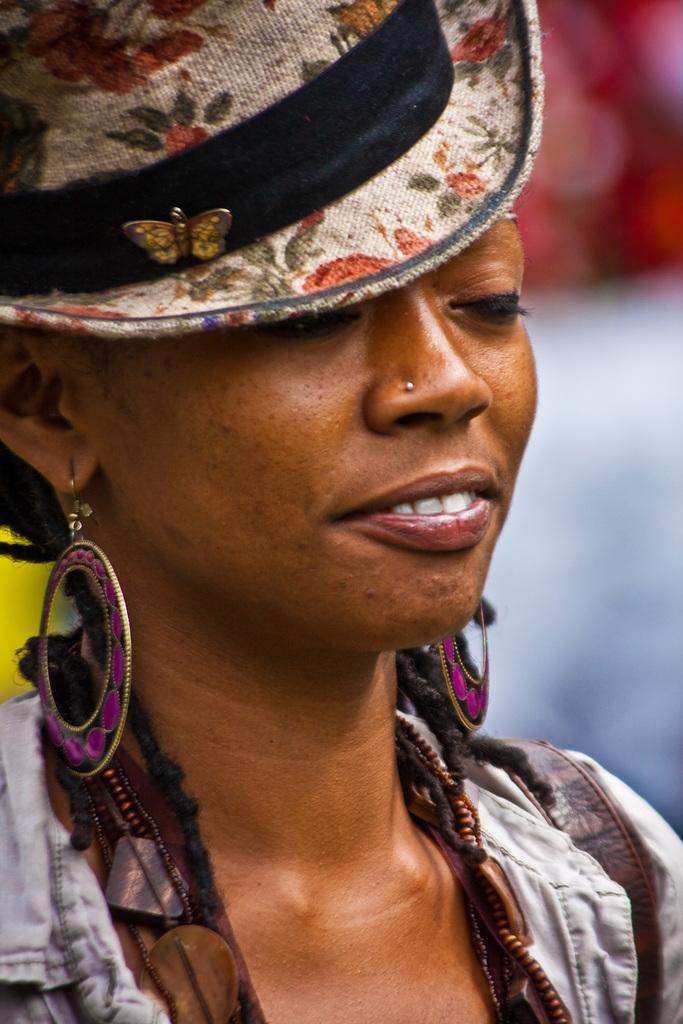Who is present in the image? There is a woman in the image. What is the woman wearing on her head? The woman is wearing a cap. Can you describe the background of the image? The background of the image is blurred. What type of suit is the woman wearing in the garden? There is no suit or garden present in the image; the woman is wearing a cap, and the background is blurred. 